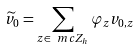Convert formula to latex. <formula><loc_0><loc_0><loc_500><loc_500>\widetilde { v } _ { 0 } = \sum _ { z \in \ m c Z _ { h } } \varphi _ { z } v _ { 0 , z }</formula> 